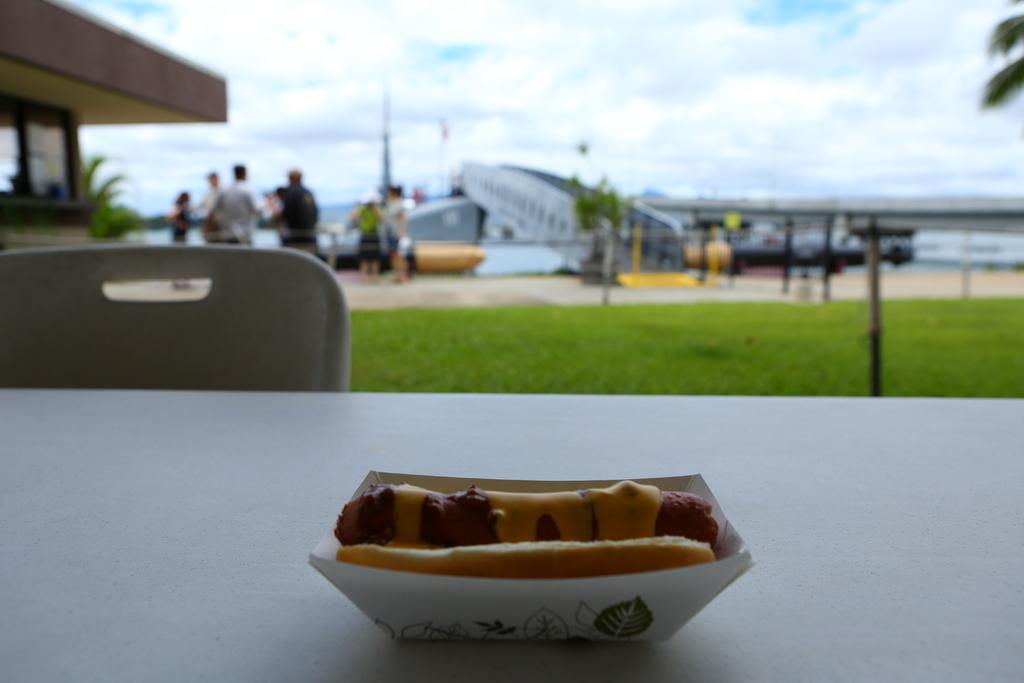Could you give a brief overview of what you see in this image? In this picture we can see a hot dog on a table, chair, grass, building, trees and some people and in the background we can see the sky with clouds. 